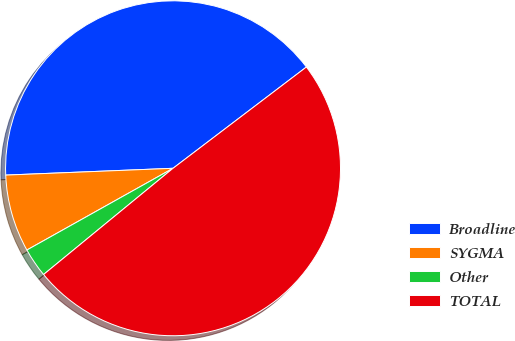<chart> <loc_0><loc_0><loc_500><loc_500><pie_chart><fcel>Broadline<fcel>SYGMA<fcel>Other<fcel>TOTAL<nl><fcel>40.31%<fcel>7.47%<fcel>2.82%<fcel>49.4%<nl></chart> 